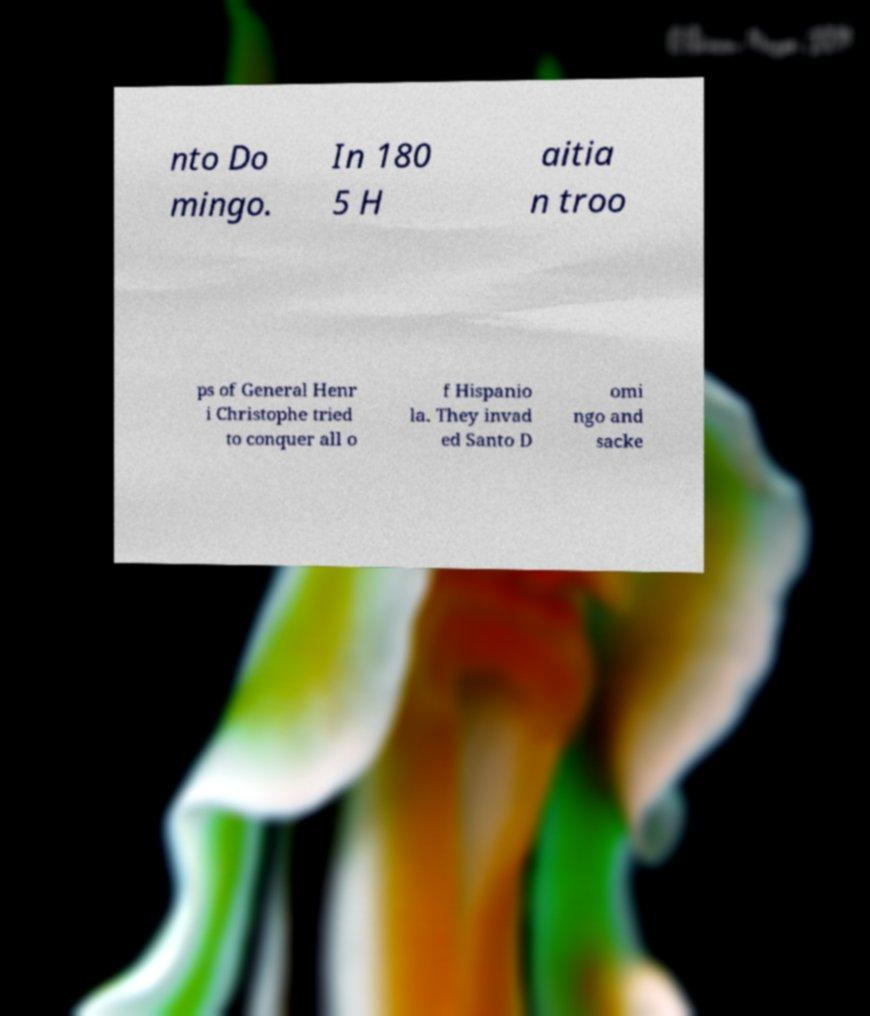There's text embedded in this image that I need extracted. Can you transcribe it verbatim? nto Do mingo. In 180 5 H aitia n troo ps of General Henr i Christophe tried to conquer all o f Hispanio la. They invad ed Santo D omi ngo and sacke 